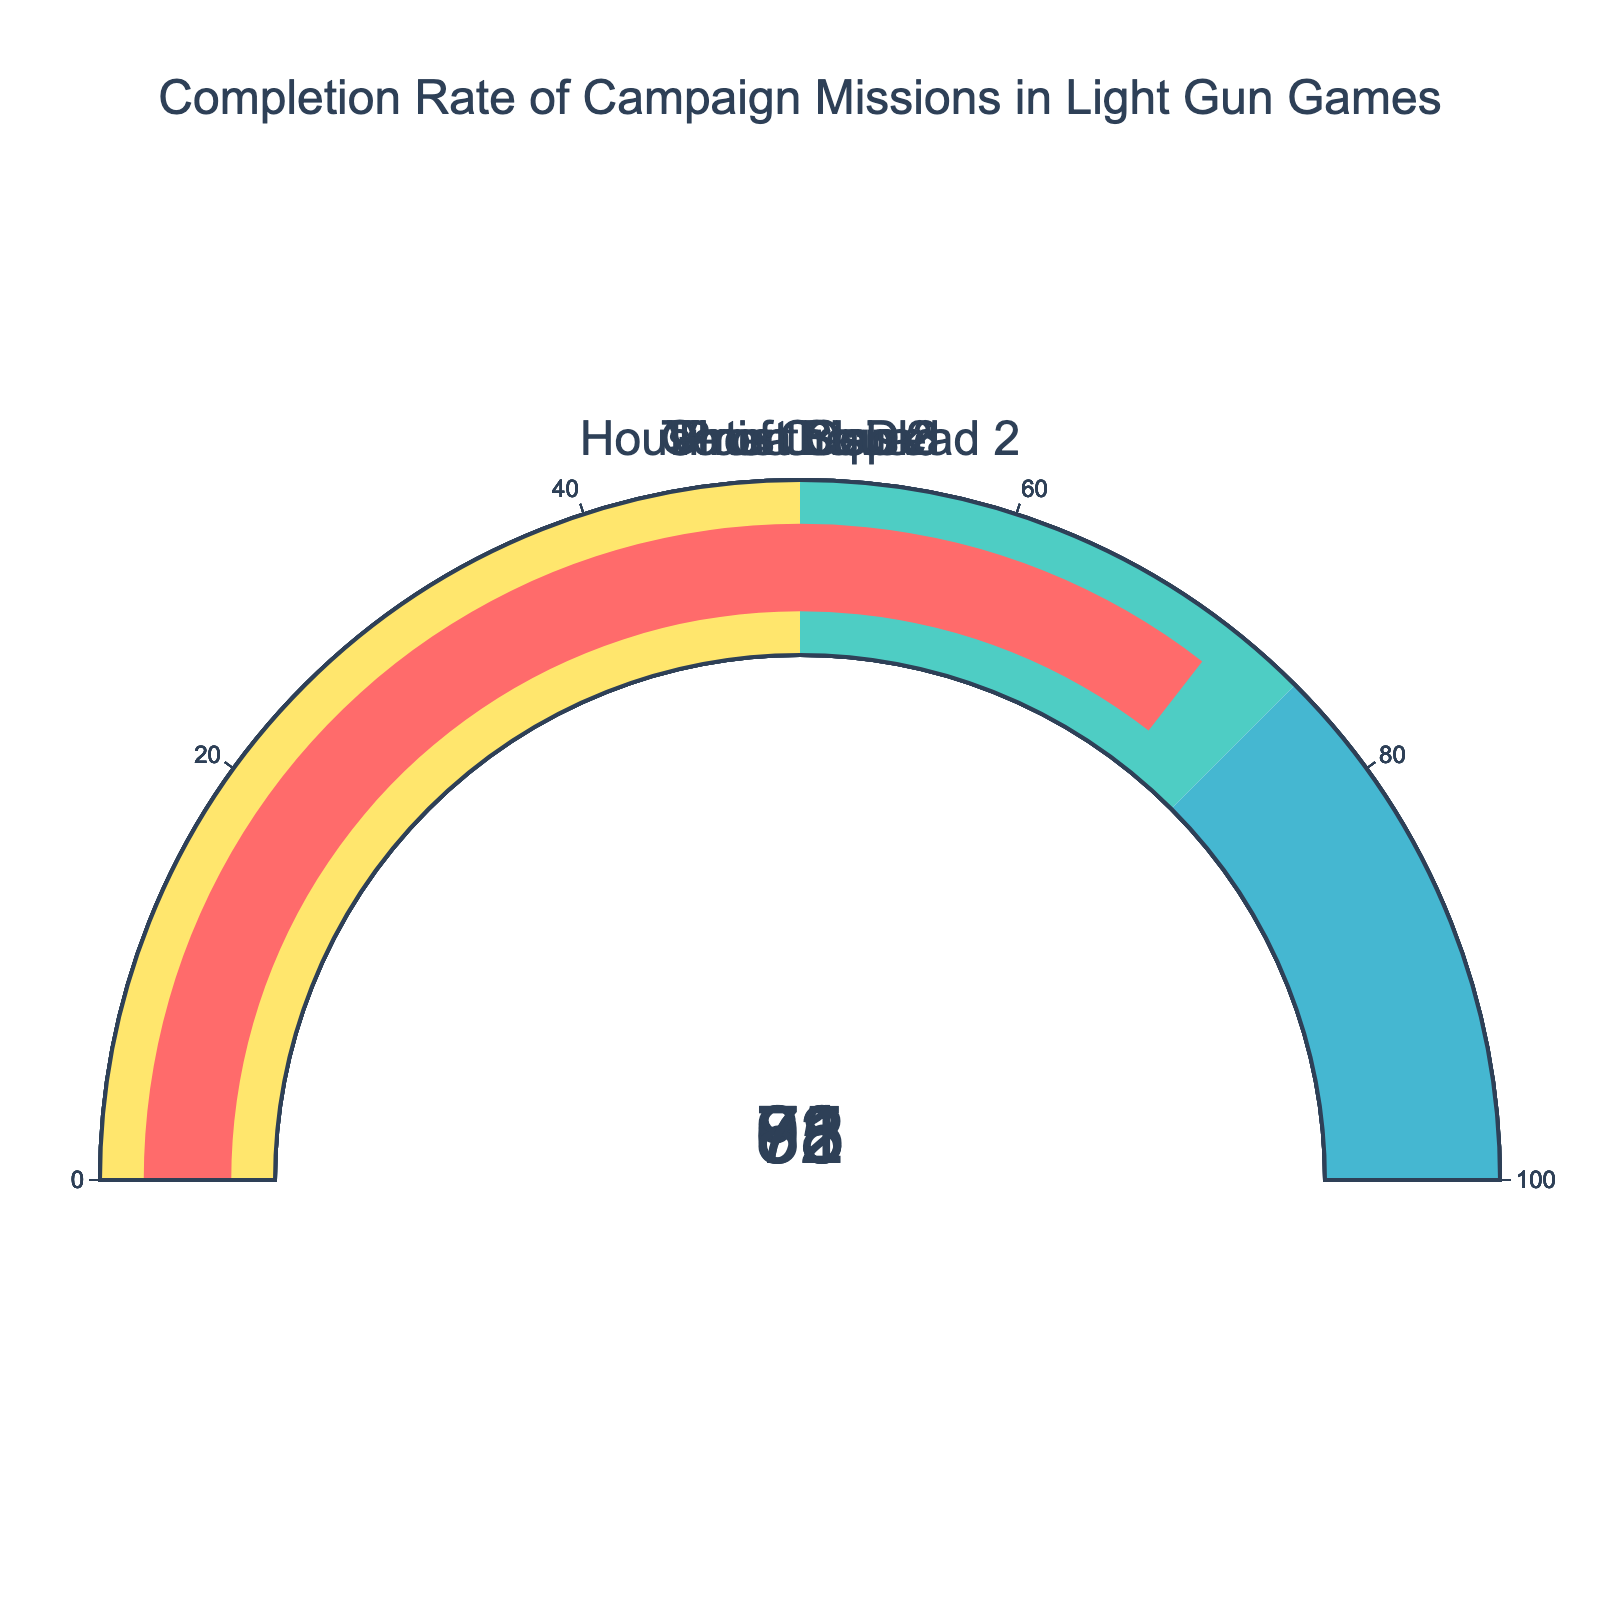Which game has the highest completion rate? Among the gauges, "Point Blank" shows the highest completion rate with 92%.
Answer: Point Blank Which game has the lowest completion rate? Among the data points, "House of the Dead 2" has the lowest completion rate of 65%.
Answer: House of the Dead 2 What is the range of completion rates? The range is calculated as the highest value minus the lowest value. So, it is 92% (Point Blank) - 65% (House of the Dead 2).
Answer: 27% How many games have a completion rate above 75%? By inspecting the gauges, three games have completion rates above 75%: "Time Crisis 3", "Point Blank", and "Virtua Cop 2".
Answer: 3 What's the average completion rate of all the games? Calculate the average by summing the completion rates and dividing by the number of games: (78 + 65 + 92 + 83 + 71) / 5 = 389 / 5 = 77.8%.
Answer: 77.8% How much higher is the completion rate of "Point Blank" compared to "Ghost Squad"? Subtract the completion rate of "Ghost Squad" from "Point Blank": 92% - 71% = 21%.
Answer: 21% Which games have completion rates within the range of 60% to 80%? The games that fall within the 60% to 80% range are: "Time Crisis 3", "House of the Dead 2", and "Ghost Squad".
Answer: Time Crisis 3, House of the Dead 2, Ghost Squad Are there more games with completion rates above 75% or below 75%? By counting the gauges, there are three games above 75% and two games below 75%. Thus, there are more games with completion rates above 75%.
Answer: Above 75% What is the median completion rate? With five values (65, 71, 78, 83, 92), the median is the middle one when ordered, which is 78%.
Answer: 78% Which completion rate appears in the middle range of the color-coded gauge steps? The middle range on the gauges (50-75%) includes completion rates of 65% and 71%.
Answer: 65%, 71% 